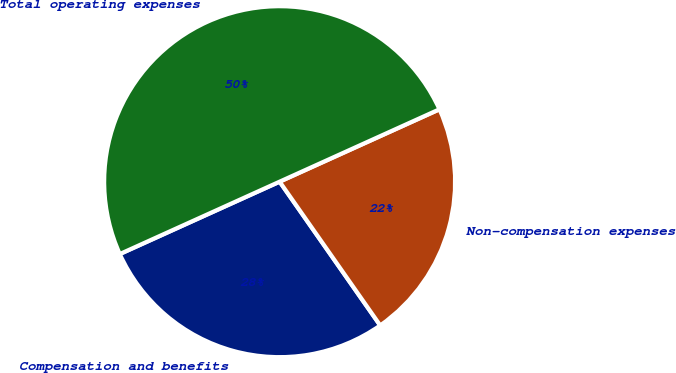Convert chart. <chart><loc_0><loc_0><loc_500><loc_500><pie_chart><fcel>Compensation and benefits<fcel>Non-compensation expenses<fcel>Total operating expenses<nl><fcel>27.95%<fcel>22.05%<fcel>50.0%<nl></chart> 